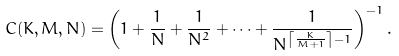Convert formula to latex. <formula><loc_0><loc_0><loc_500><loc_500>C ( K , M , N ) = \left ( 1 + \frac { 1 } { N } + \frac { 1 } { N ^ { 2 } } + \dots + \frac { 1 } { N ^ { \left \lceil \frac { K } { M + 1 } \right \rceil - 1 } } \right ) ^ { - 1 } .</formula> 